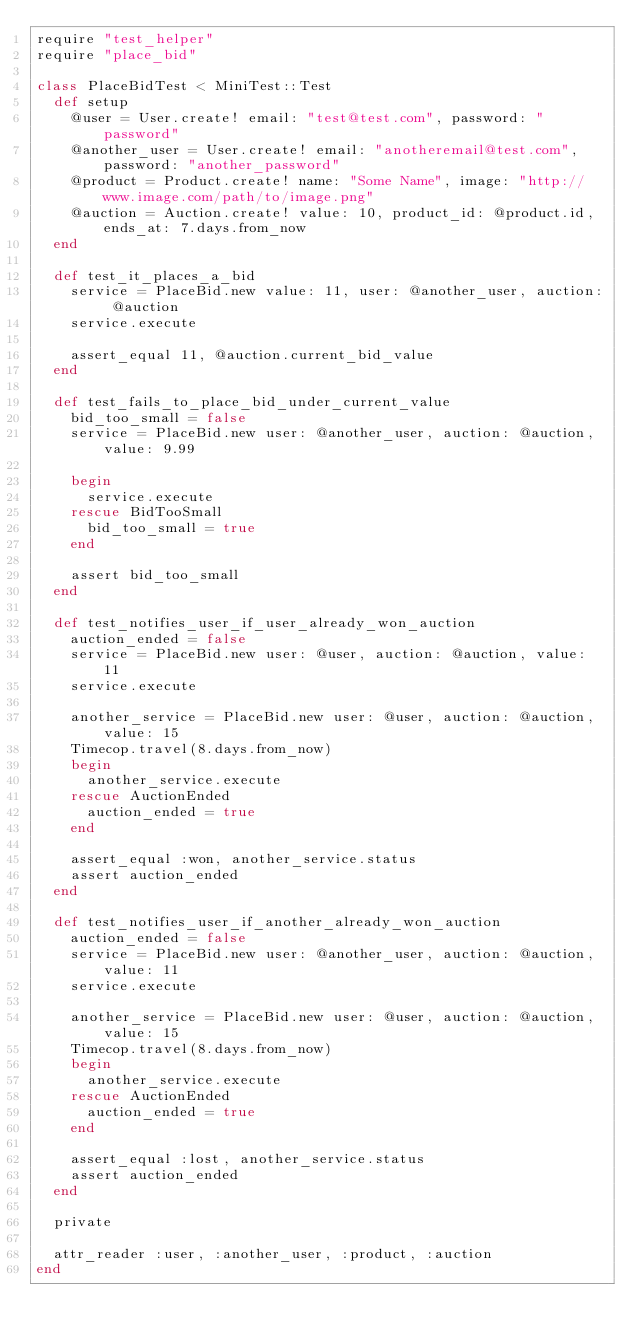Convert code to text. <code><loc_0><loc_0><loc_500><loc_500><_Ruby_>require "test_helper"
require "place_bid"

class PlaceBidTest < MiniTest::Test
  def setup
    @user = User.create! email: "test@test.com", password: "password"
    @another_user = User.create! email: "anotheremail@test.com", password: "another_password"
    @product = Product.create! name: "Some Name", image: "http://www.image.com/path/to/image.png"
    @auction = Auction.create! value: 10, product_id: @product.id, ends_at: 7.days.from_now
  end

  def test_it_places_a_bid
    service = PlaceBid.new value: 11, user: @another_user, auction: @auction
    service.execute

    assert_equal 11, @auction.current_bid_value
  end

  def test_fails_to_place_bid_under_current_value
    bid_too_small = false
    service = PlaceBid.new user: @another_user, auction: @auction, value: 9.99

    begin
      service.execute
    rescue BidTooSmall
      bid_too_small = true
    end

    assert bid_too_small
  end

  def test_notifies_user_if_user_already_won_auction
    auction_ended = false
    service = PlaceBid.new user: @user, auction: @auction, value: 11
    service.execute

    another_service = PlaceBid.new user: @user, auction: @auction, value: 15
    Timecop.travel(8.days.from_now)
    begin
      another_service.execute
    rescue AuctionEnded
      auction_ended = true
    end

    assert_equal :won, another_service.status
    assert auction_ended
  end

  def test_notifies_user_if_another_already_won_auction
    auction_ended = false
    service = PlaceBid.new user: @another_user, auction: @auction, value: 11
    service.execute

    another_service = PlaceBid.new user: @user, auction: @auction, value: 15
    Timecop.travel(8.days.from_now)
    begin
      another_service.execute
    rescue AuctionEnded
      auction_ended = true
    end

    assert_equal :lost, another_service.status
    assert auction_ended
  end

  private

  attr_reader :user, :another_user, :product, :auction
end
</code> 